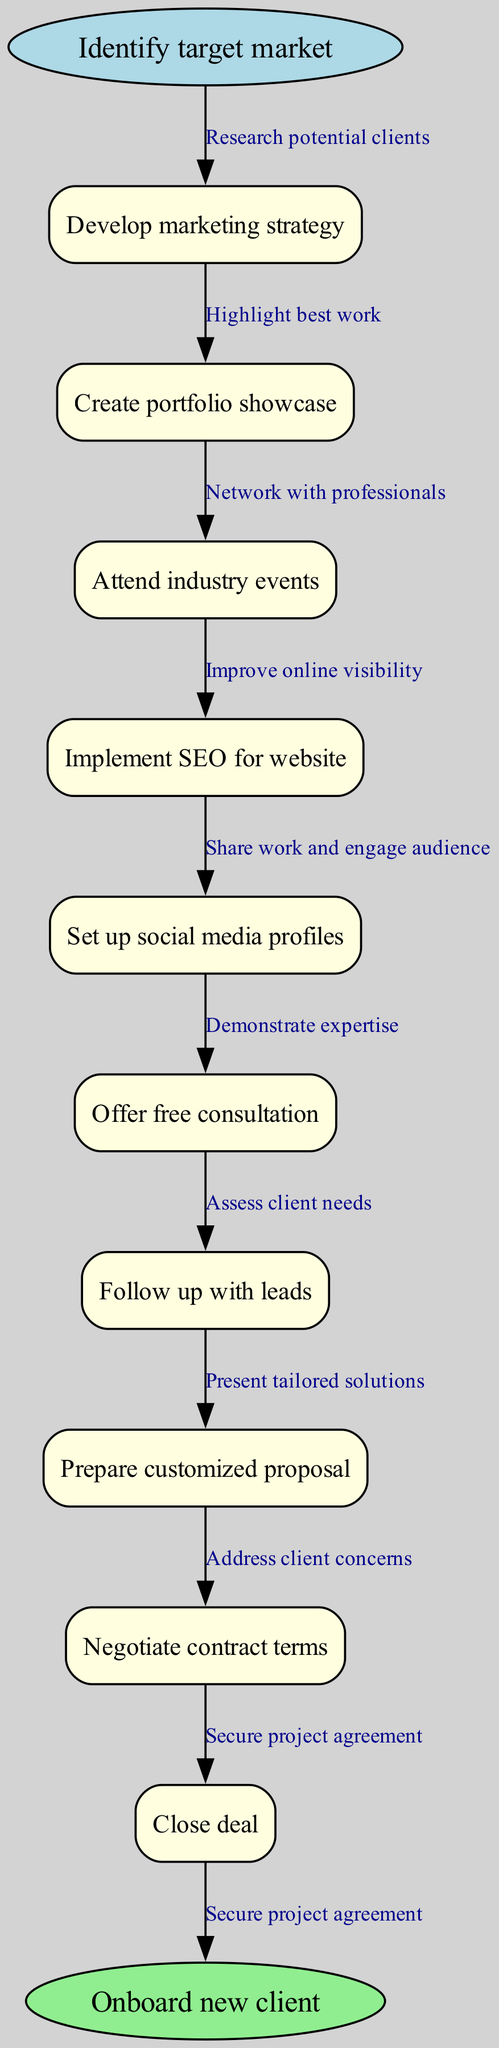What is the starting point of the diagram? The starting point is identified as "Identify target market", which is explicitly labeled at the beginning of the flowchart.
Answer: Identify target market How many nodes are present in the diagram? By counting the nodes listed, there are a total of 10 intermediate nodes in addition to the start and end nodes. Therefore, the total is 12 nodes.
Answer: 12 What is the ending point of the diagram? The endpoint is labeled "Onboard new client", indicating the final stage of the process.
Answer: Onboard new client Which node follows "Attend industry events"? Following "Attend industry events", the next node in the flow is "Implement SEO for website". This is determined by the sequential arrangement of nodes connected in the flowchart.
Answer: Implement SEO for website How many edges are connected to the "Create portfolio showcase" node? The "Create portfolio showcase" node has one incoming edge from "Develop marketing strategy" and one outgoing edge leading to "Attend industry events". Therefore, it has a total of 2 connected edges.
Answer: 2 What is the relationship between "Offer free consultation" and "Follow up with leads"? The relationship indicates a sequence where "Offer free consultation" leads into "Follow up with leads". This indicates that after offering a free consultation, the next step is to follow up with potential clients.
Answer: Sequential What is the last action performed before closing the deal? The action taken just before closing the deal is to "Negotiate contract terms". This step is directly connected to the closing process in the flowchart.
Answer: Negotiate contract terms Which node is linked to the edge "Demonstrate expertise"? The node linked to the edge "Demonstrate expertise" is "Offer free consultation", as it demonstrates expertise through personal engagement with the client.
Answer: Offer free consultation What is the total number of edges in the diagram? There are 10 edges described in the flowchart, each connecting the nodes sequentially from the start to the endpoint including all intermediate connections.
Answer: 10 